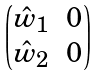<formula> <loc_0><loc_0><loc_500><loc_500>\begin{pmatrix} \hat { w } _ { 1 } & 0 \\ \hat { w } _ { 2 } & 0 \end{pmatrix}</formula> 